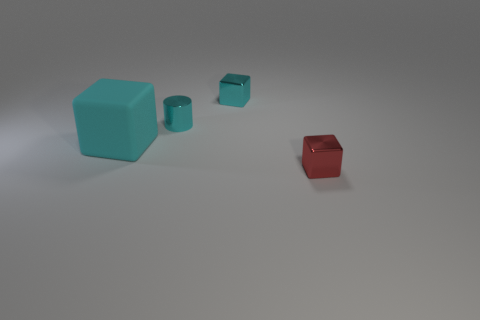Subtract all cyan matte cubes. How many cubes are left? 2 Add 2 red metallic blocks. How many red metallic blocks are left? 3 Add 4 small yellow cylinders. How many small yellow cylinders exist? 4 Add 1 large things. How many objects exist? 5 Subtract all red blocks. How many blocks are left? 2 Subtract 0 yellow cylinders. How many objects are left? 4 Subtract all blocks. How many objects are left? 1 Subtract 2 blocks. How many blocks are left? 1 Subtract all yellow cylinders. Subtract all green cubes. How many cylinders are left? 1 Subtract all green balls. How many red blocks are left? 1 